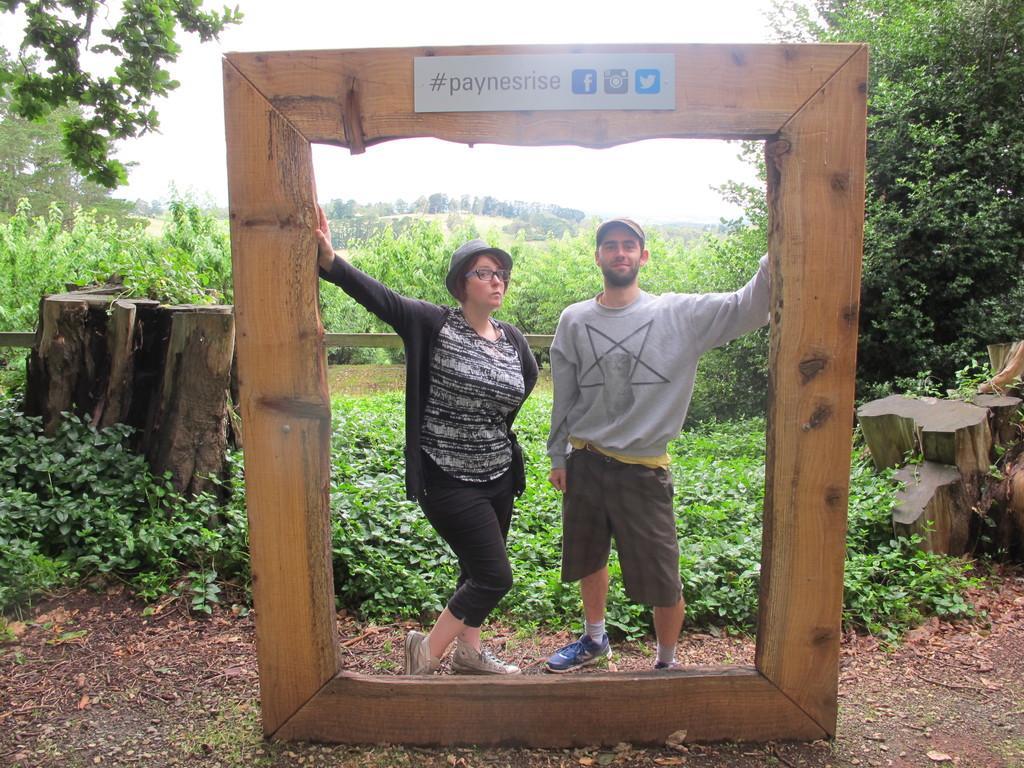Could you give a brief overview of what you see in this image? In this picture we can see a man and a woman, they wore caps, behind to them we can see few plants and trees. 